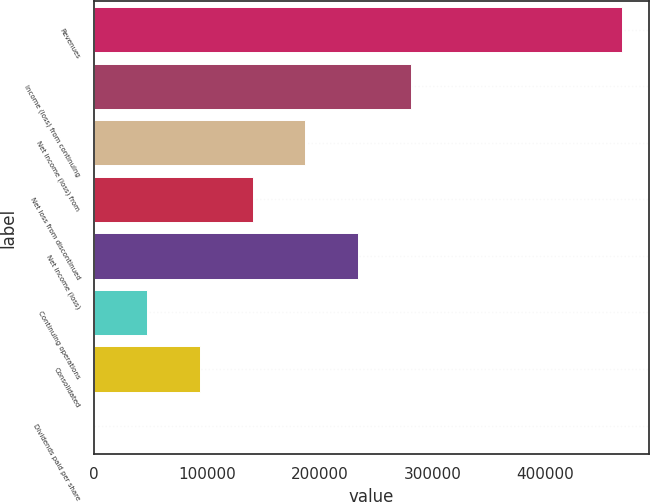Convert chart to OTSL. <chart><loc_0><loc_0><loc_500><loc_500><bar_chart><fcel>Revenues<fcel>Income (loss) from continuing<fcel>Net income (loss) from<fcel>Net loss from discontinued<fcel>Net income (loss)<fcel>Continuing operations<fcel>Consolidated<fcel>Dividends paid per share<nl><fcel>468384<fcel>281030<fcel>187354<fcel>140515<fcel>234192<fcel>46838.6<fcel>93677<fcel>0.25<nl></chart> 